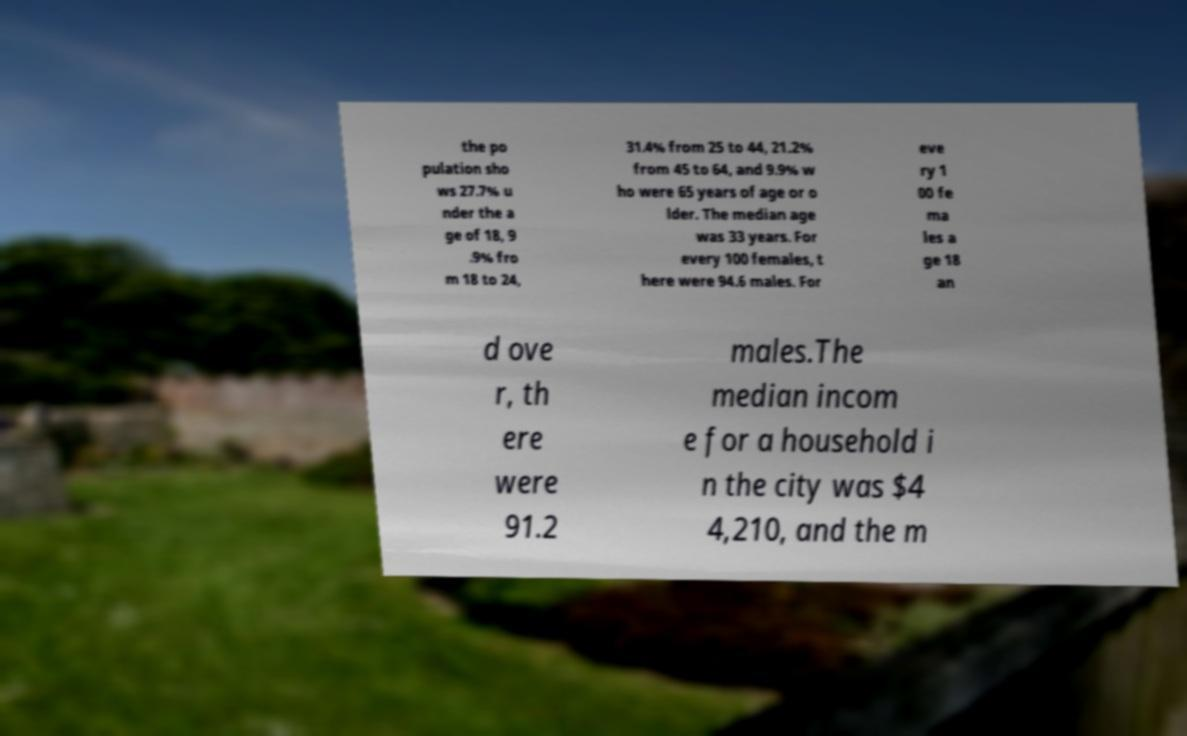Please identify and transcribe the text found in this image. the po pulation sho ws 27.7% u nder the a ge of 18, 9 .9% fro m 18 to 24, 31.4% from 25 to 44, 21.2% from 45 to 64, and 9.9% w ho were 65 years of age or o lder. The median age was 33 years. For every 100 females, t here were 94.6 males. For eve ry 1 00 fe ma les a ge 18 an d ove r, th ere were 91.2 males.The median incom e for a household i n the city was $4 4,210, and the m 